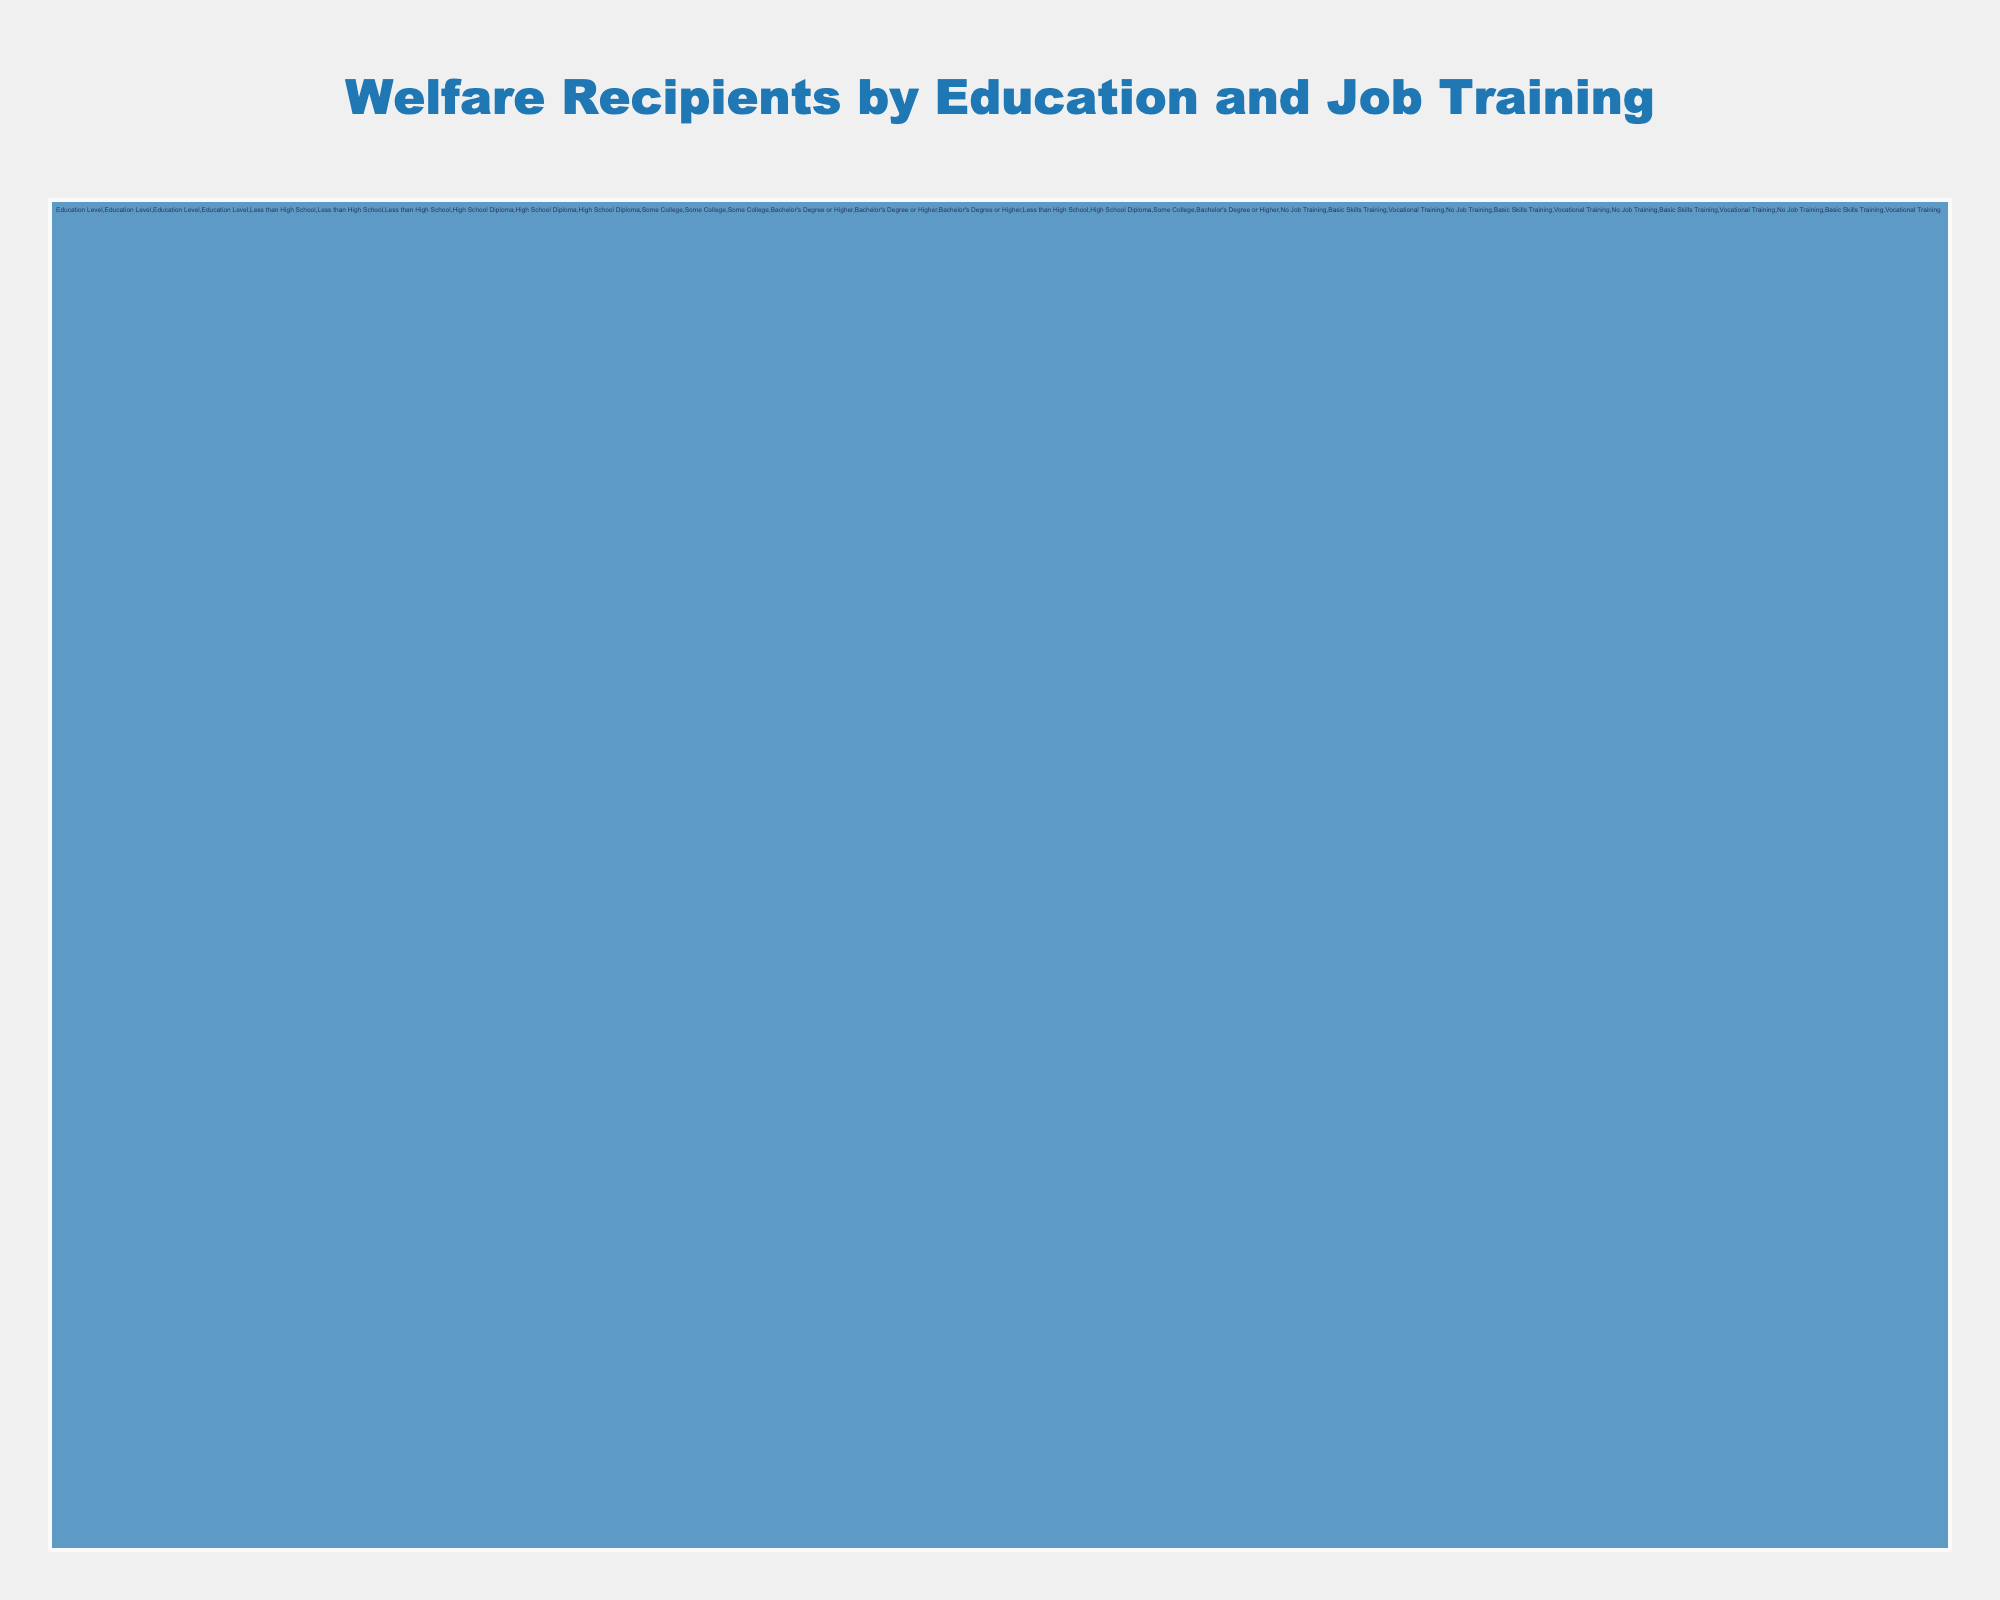What is the title of the figure? The title of the figure is typically placed at the top-center of the chart and is designed to give an overview of what the chart represents. In this case, the title is given in the code.
Answer: Welfare Recipients by Education and Job Training Which category has the most welfare recipients? To determine which category has the most welfare recipients, look at the highest value under the "Education Level" category. The data shows "High School Diploma" has the highest value at 150.
Answer: High School Diploma How many welfare recipients with "Less than High School" education participated in "Vocational Training"? Locate the "Less than High School" branch and then find the "Vocational Training" sub-branch under it. The data indicates 15 welfare recipients in this category.
Answer: 15 What is the total number of welfare recipients with "Some College" education? The total number for "Some College" is directly given in the data as 80. Sum of subcategories under "Some College" confirms this (30+20+30).
Answer: 80 Which subcategory within "Bachelor's Degree or Higher" education has the highest number of recipients? For this, look at the subcategories under "Bachelor's Degree or Higher." The "No Job Training" subcategory has the highest value at 40.
Answer: No Job Training Compare the number of recipients with "Basic Skills Training" in "Less than High School" and "High School Diploma" levels. Which is higher and by how much? For "Less than High School", recipients with "Basic Skills Training" are 25, and for "High School Diploma" it is 45. Subtracting these gives 45 - 25 = 20.
Answer: High School Diploma by 20 What is the combined total of welfare recipients who have "No Job Training" across all education levels? Sum the "No Job Training" values across all education levels: 60 (Less than High School) + 70 (High School Diploma) + 30 (Some College) + 40 (Bachelor's Degree or Higher) = 200.
Answer: 200 Within the "Some College" education level, which job training type has the fewest recipients? Under "Some College", compare values across "No Job Training" (30), "Basic Skills Training" (20), and "Vocational Training" (30). "Basic Skills Training" is the fewest at 20.
Answer: Basic Skills Training What percentage of welfare recipients with "High School Diploma" have "Vocational Training"? For "High School Diploma", the total is 150. Those with "Vocational Training" are 35. Calculating the percentage: (35/150)*100 ≈ 23.33%.
Answer: Approximately 23.33% What is the total number of welfare recipients across all education levels? Add up the total values for each education level: 100 (Less than High School) + 150 (High School Diploma) + 80 (Some College) + 70 (Bachelor's Degree or Higher) = 400.
Answer: 400 